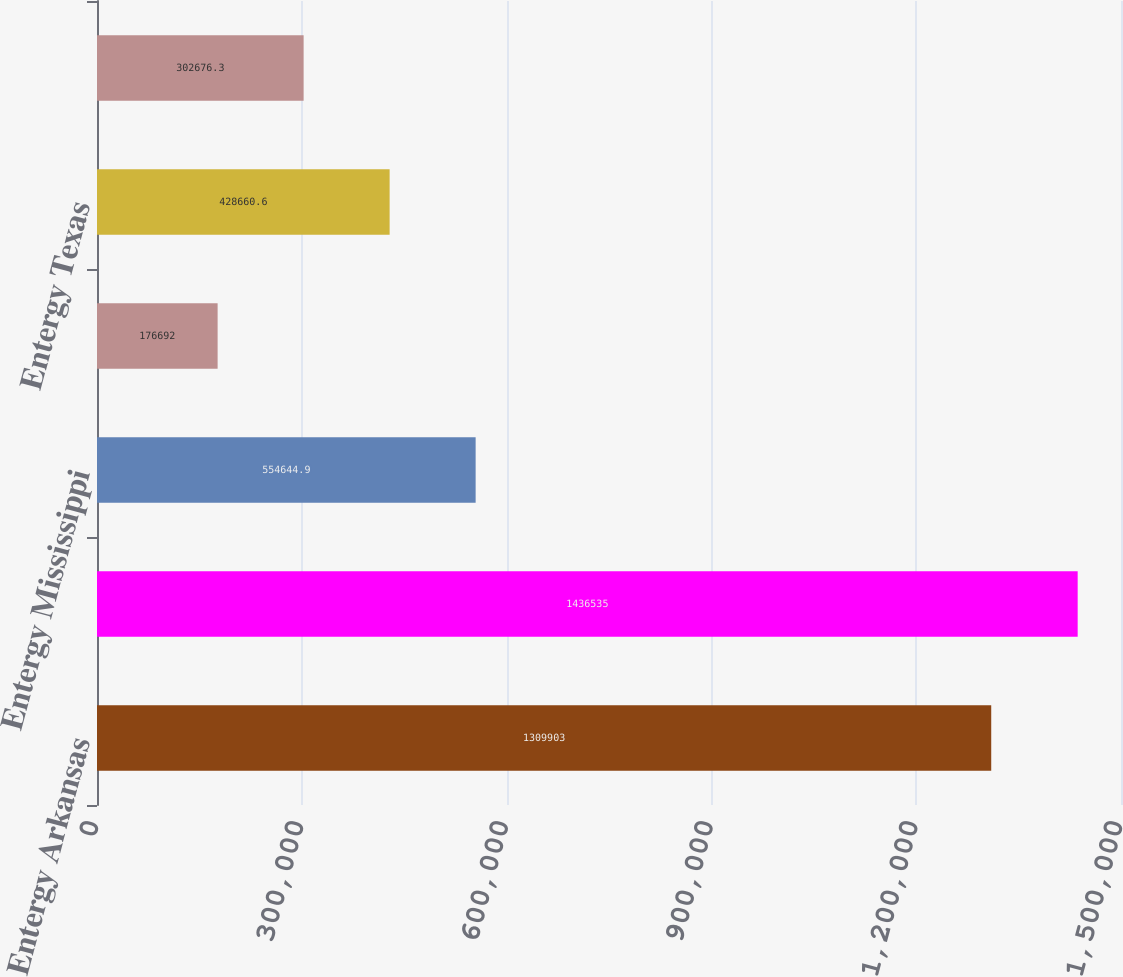<chart> <loc_0><loc_0><loc_500><loc_500><bar_chart><fcel>Entergy Arkansas<fcel>Entergy Louisiana<fcel>Entergy Mississippi<fcel>Entergy New Orleans<fcel>Entergy Texas<fcel>System Energy<nl><fcel>1.3099e+06<fcel>1.43654e+06<fcel>554645<fcel>176692<fcel>428661<fcel>302676<nl></chart> 